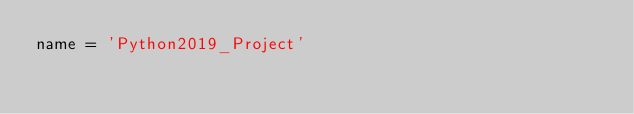<code> <loc_0><loc_0><loc_500><loc_500><_Python_>name = 'Python2019_Project'</code> 